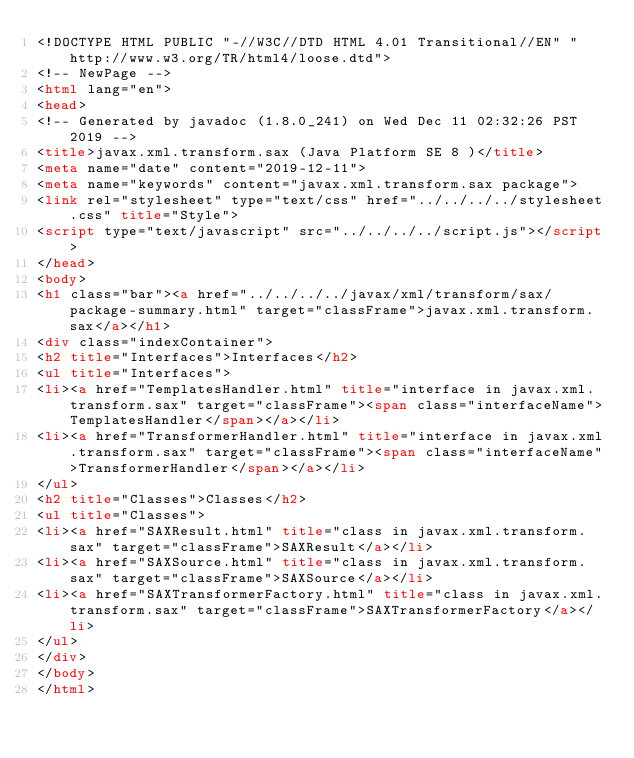<code> <loc_0><loc_0><loc_500><loc_500><_HTML_><!DOCTYPE HTML PUBLIC "-//W3C//DTD HTML 4.01 Transitional//EN" "http://www.w3.org/TR/html4/loose.dtd">
<!-- NewPage -->
<html lang="en">
<head>
<!-- Generated by javadoc (1.8.0_241) on Wed Dec 11 02:32:26 PST 2019 -->
<title>javax.xml.transform.sax (Java Platform SE 8 )</title>
<meta name="date" content="2019-12-11">
<meta name="keywords" content="javax.xml.transform.sax package">
<link rel="stylesheet" type="text/css" href="../../../../stylesheet.css" title="Style">
<script type="text/javascript" src="../../../../script.js"></script>
</head>
<body>
<h1 class="bar"><a href="../../../../javax/xml/transform/sax/package-summary.html" target="classFrame">javax.xml.transform.sax</a></h1>
<div class="indexContainer">
<h2 title="Interfaces">Interfaces</h2>
<ul title="Interfaces">
<li><a href="TemplatesHandler.html" title="interface in javax.xml.transform.sax" target="classFrame"><span class="interfaceName">TemplatesHandler</span></a></li>
<li><a href="TransformerHandler.html" title="interface in javax.xml.transform.sax" target="classFrame"><span class="interfaceName">TransformerHandler</span></a></li>
</ul>
<h2 title="Classes">Classes</h2>
<ul title="Classes">
<li><a href="SAXResult.html" title="class in javax.xml.transform.sax" target="classFrame">SAXResult</a></li>
<li><a href="SAXSource.html" title="class in javax.xml.transform.sax" target="classFrame">SAXSource</a></li>
<li><a href="SAXTransformerFactory.html" title="class in javax.xml.transform.sax" target="classFrame">SAXTransformerFactory</a></li>
</ul>
</div>
</body>
</html>
</code> 